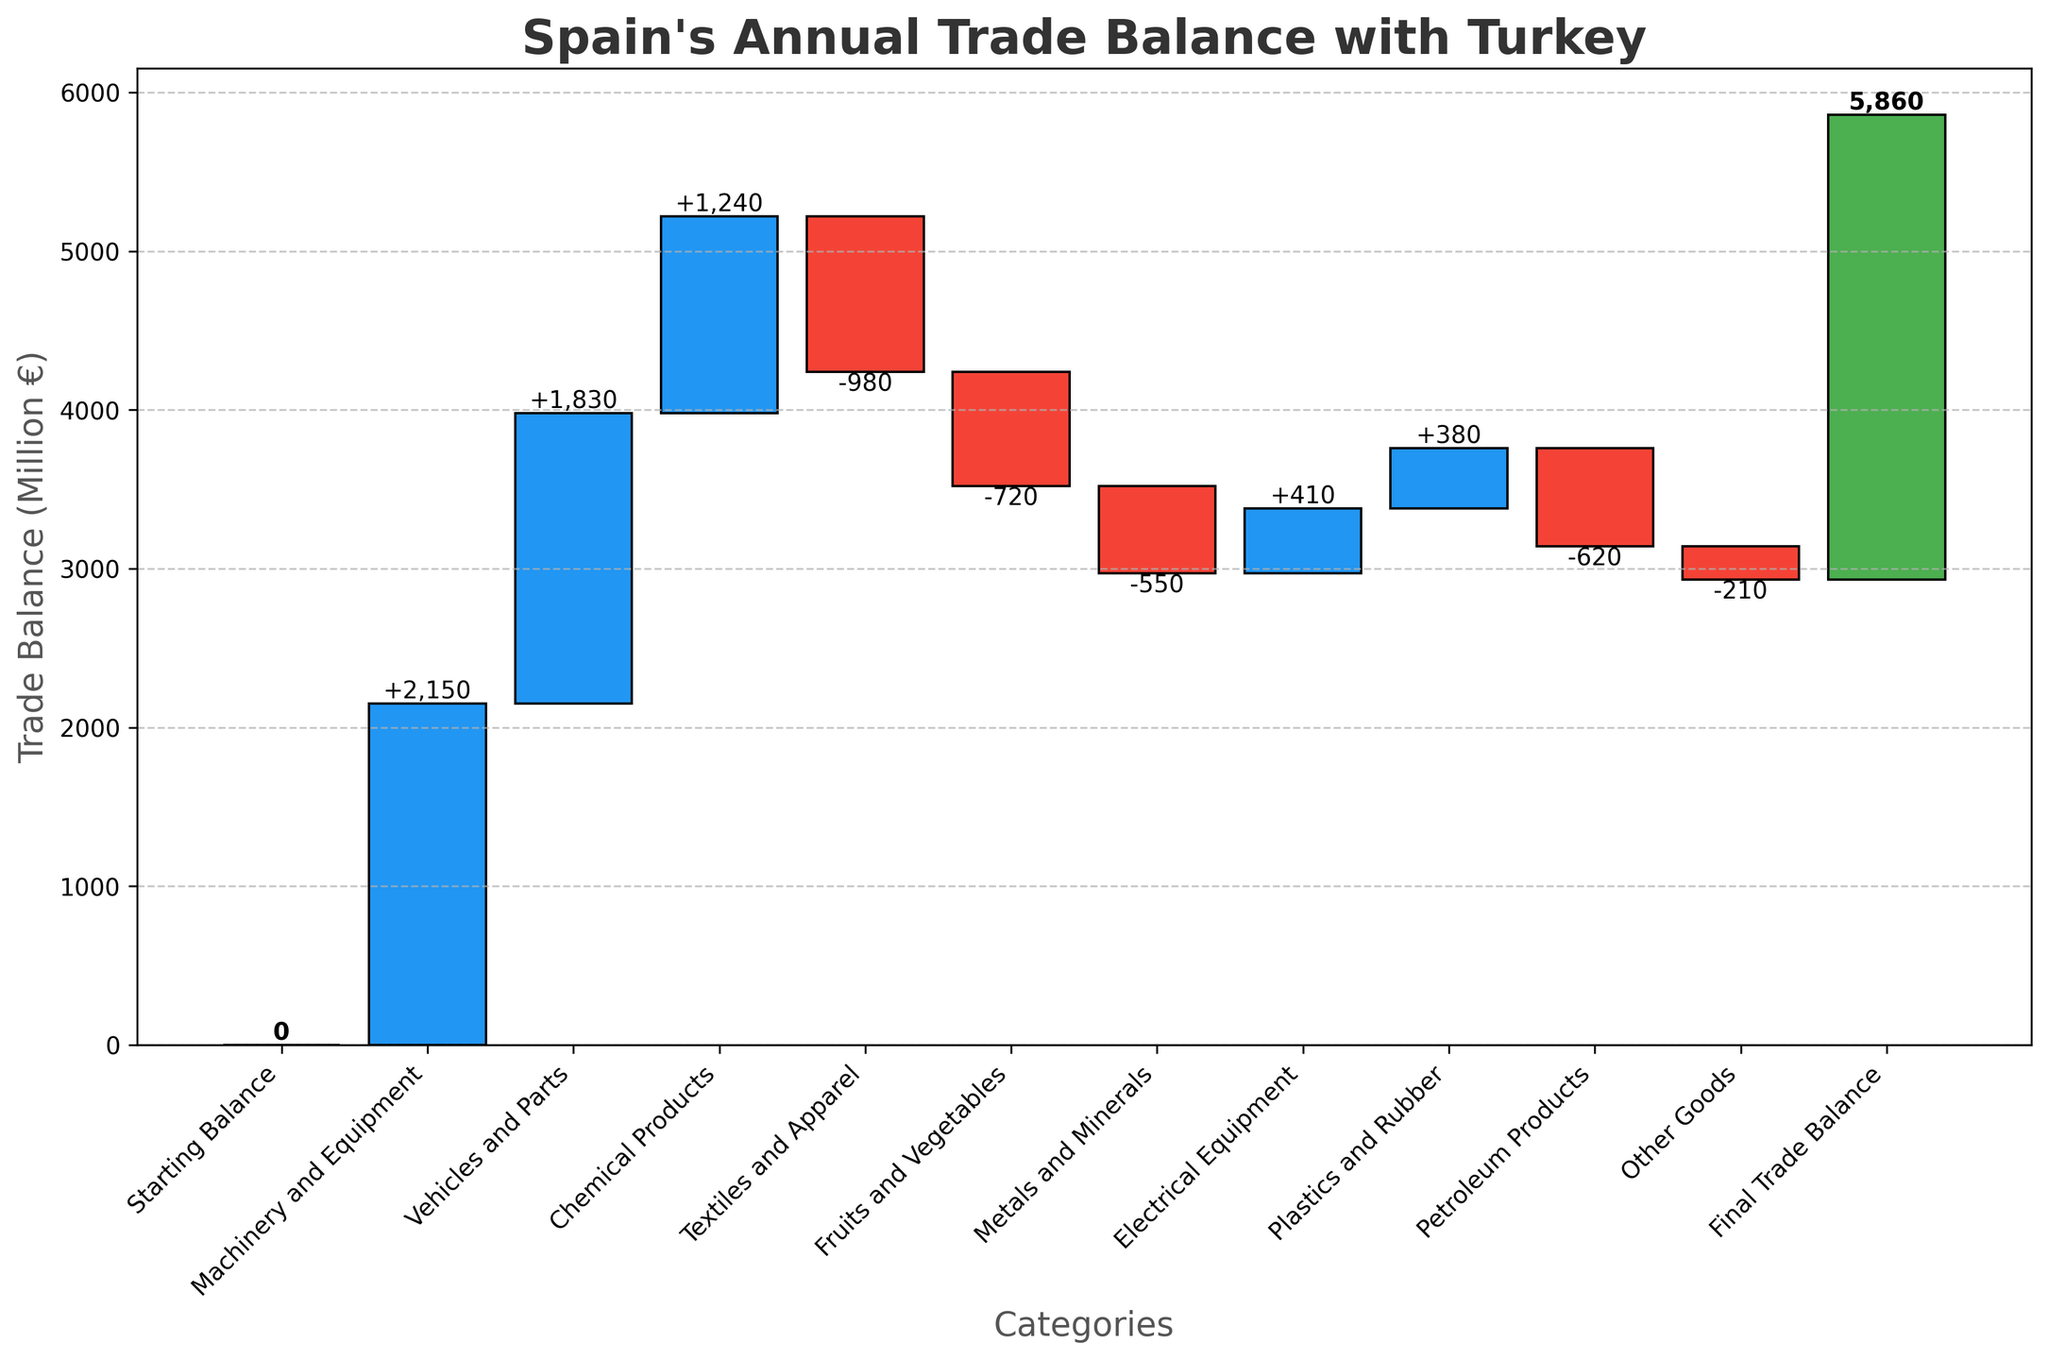What's the title of the plot? The title of the plot is displayed at the top in bold and large font. It summarizes the overall content and objective of the plot.
Answer: Spain's Annual Trade Balance with Turkey What is the total final trade balance? The final trade balance is shown at the last bar, which is also labeled explicitly with a positive or negative number. The final cumulative value is 2930€ million.
Answer: 2930€ million Which category has the highest positive contribution to the trade balance? To find the highest positive contribution, look for the tallest blue bar on the chart. The bar for 'Machinery and Equipment' is the highest among positive values.
Answer: Machinery and Equipment How much is the trade deficit in the 'Textiles and Apparel' category? Negative contributions are shown in red bars. The 'Textiles and Apparel' bar is red and its value is labeled. The label reads -980€ million.
Answer: -980€ million What are the three export categories with the largest contributions? To determine this, examine the heights and values of the blue bars (positive contributions). The three with the largest values are 'Machinery and Equipment', 'Vehicles and Parts', and 'Chemical Products'.
Answer: Machinery and Equipment, Vehicles and Parts, Chemical Products How does the trade balance change from 'Chemical Products' to 'Textiles and Apparel'? To see the change, look at the cumulative value labels before 'Textiles and Apparel' and compare them with after 'Chemical Products'. The change is from positive value to a decrease. The cumulative sum before Textiles and Apparel is 5220€ million (2150+1830+1240) and after is 4240€ million (5220 - 980).
Answer: Decreases by 980€ million What's the difference between the contributions of 'Fruits and Vegetables' and 'Metals and Minerals'? Compare the heights and values of the 'Fruits and Vegetables' and 'Metals and Minerals' red bars. 'Fruits and Vegetables' is -720€ million and 'Metals and Minerals' is -550€ million. The difference is -720 - (-550) = -170€ million.
Answer: -170€ million How many categories have a negative contribution? Count the number of red bars in the figure. The categories with negative contributions are 'Textiles and Apparel', 'Fruits and Vegetables', 'Metals and Minerals', and 'Petroleum Products', and 'Other Goods'.
Answer: 5 Which categories resulted in the final positive trade balance and played a role in the net surplus? Adding up contributions that sum to a positive final balance (green bar) reflects the net surplus. The categories are blue bars 'Machinery and Equipment', 'Vehicles and Parts', 'Chemical Products', 'Electrical Equipment', and 'Plastics and Rubber'.
Answer: Machinery and Equipment, Vehicles and Parts, Chemical Products, Electrical Equipment, Plastics and Rubber 